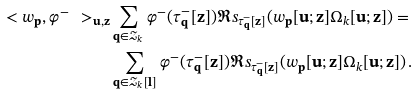Convert formula to latex. <formula><loc_0><loc_0><loc_500><loc_500>\ < w _ { \mathbf p } , \varphi ^ { - } \ > _ { \mathbf u , \mathbf z } & \sum _ { \mathbf q \in \mathcal { Z } _ { k } } \varphi ^ { - } ( \tau ^ { - } _ { \mathbf q } [ \mathbf z ] ) \Re s _ { \tau ^ { - } _ { \mathbf q } [ \mathbf z ] } ( w _ { \mathbf p } [ \mathbf u ; \mathbf z ] \Omega _ { k } [ \mathbf u ; \mathbf z ] ) = \\ & \sum _ { \mathbf q \in \mathcal { Z } _ { k } [ \mathbf l ] } \varphi ^ { - } ( \tau ^ { - } _ { \mathbf q } [ \mathbf z ] ) \Re s _ { \tau ^ { - } _ { \mathbf q } [ \mathbf z ] } ( w _ { \mathbf p } [ \mathbf u ; \mathbf z ] \Omega _ { k } [ \mathbf u ; \mathbf z ] ) \, .</formula> 